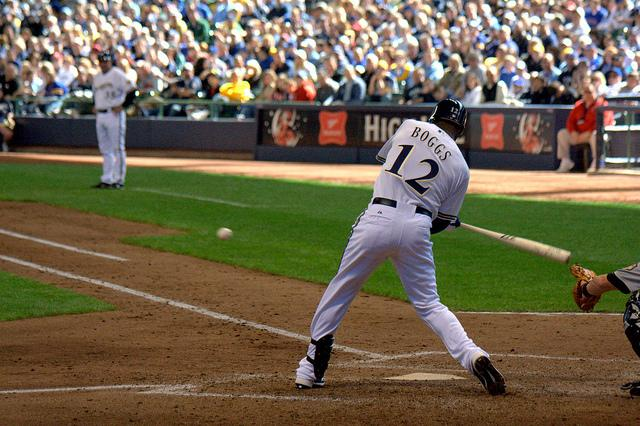Why cricketers wear white? Please explain your reasoning. reduces heat. The question is unrelated to the image, but is internet searchable. 